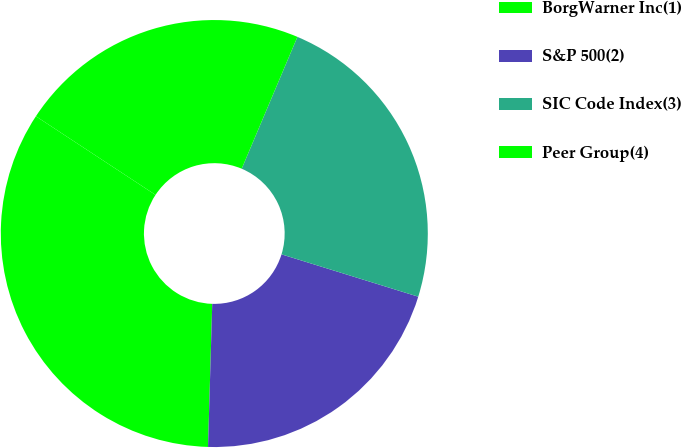Convert chart to OTSL. <chart><loc_0><loc_0><loc_500><loc_500><pie_chart><fcel>BorgWarner Inc(1)<fcel>S&P 500(2)<fcel>SIC Code Index(3)<fcel>Peer Group(4)<nl><fcel>33.79%<fcel>20.69%<fcel>23.42%<fcel>22.11%<nl></chart> 